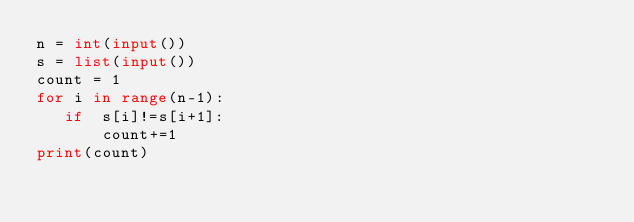<code> <loc_0><loc_0><loc_500><loc_500><_Python_>n = int(input())
s = list(input())
count = 1
for i in range(n-1):
   if  s[i]!=s[i+1]:
       count+=1
print(count)</code> 